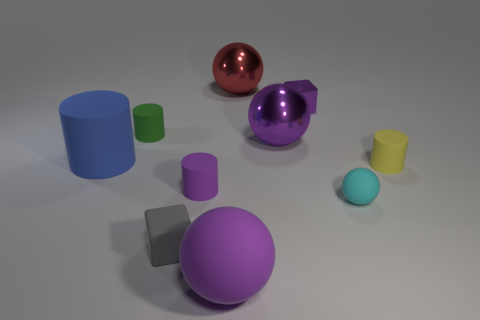There is a purple object that is the same shape as the small gray thing; what is its material?
Offer a terse response. Metal. Are there fewer large rubber things that are in front of the tiny yellow thing than red matte blocks?
Provide a short and direct response. No. Do the big matte thing in front of the tiny matte cube and the yellow thing have the same shape?
Provide a short and direct response. No. Are there any other things that have the same color as the matte cube?
Provide a succinct answer. No. What size is the blue object that is made of the same material as the purple cylinder?
Offer a terse response. Large. There is a thing that is behind the cube that is behind the big purple object that is behind the small purple matte cylinder; what is its material?
Ensure brevity in your answer.  Metal. Are there fewer tiny brown metal things than small green cylinders?
Make the answer very short. Yes. Is the small gray cube made of the same material as the green object?
Give a very brief answer. Yes. The large thing that is the same color as the large rubber ball is what shape?
Give a very brief answer. Sphere. Is the color of the tiny thing behind the green object the same as the large matte sphere?
Your answer should be compact. Yes. 